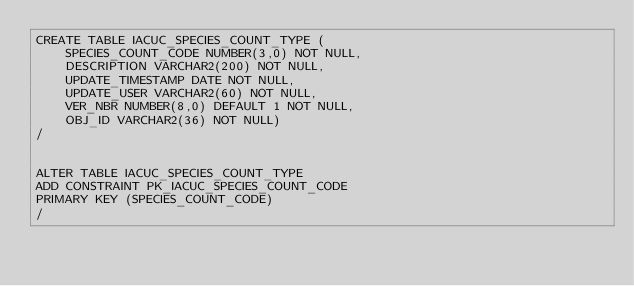<code> <loc_0><loc_0><loc_500><loc_500><_SQL_>CREATE TABLE IACUC_SPECIES_COUNT_TYPE ( 
    SPECIES_COUNT_CODE NUMBER(3,0) NOT NULL, 
    DESCRIPTION VARCHAR2(200) NOT NULL, 
    UPDATE_TIMESTAMP DATE NOT NULL, 
    UPDATE_USER VARCHAR2(60) NOT NULL, 
    VER_NBR NUMBER(8,0) DEFAULT 1 NOT NULL, 
    OBJ_ID VARCHAR2(36) NOT NULL) 
/


ALTER TABLE IACUC_SPECIES_COUNT_TYPE 
ADD CONSTRAINT PK_IACUC_SPECIES_COUNT_CODE 
PRIMARY KEY (SPECIES_COUNT_CODE) 
/

</code> 